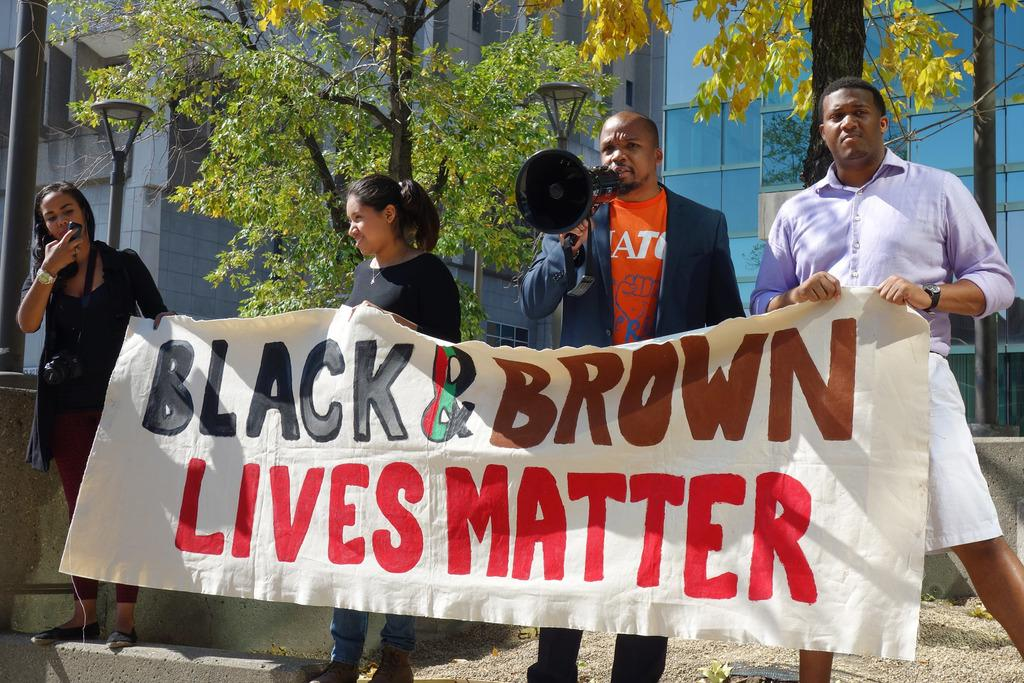How many people are present in the image? Four persons are standing in the image. What are the persons holding in the image? The persons are holding a banner and a microphone. What can be seen in the background of the image? Trees, poles, and buildings are visible in the background. Can you see any fish swimming in the image? There are no fish visible in the image. Is there a cave present in the image? There is no cave present in the image. 